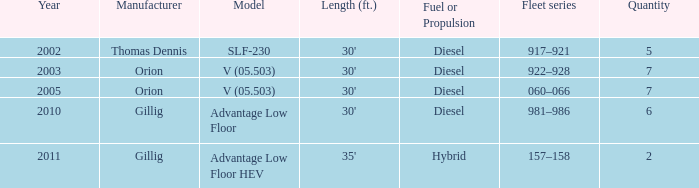Name the sum of quantity for before 2011 model slf-230 5.0. 